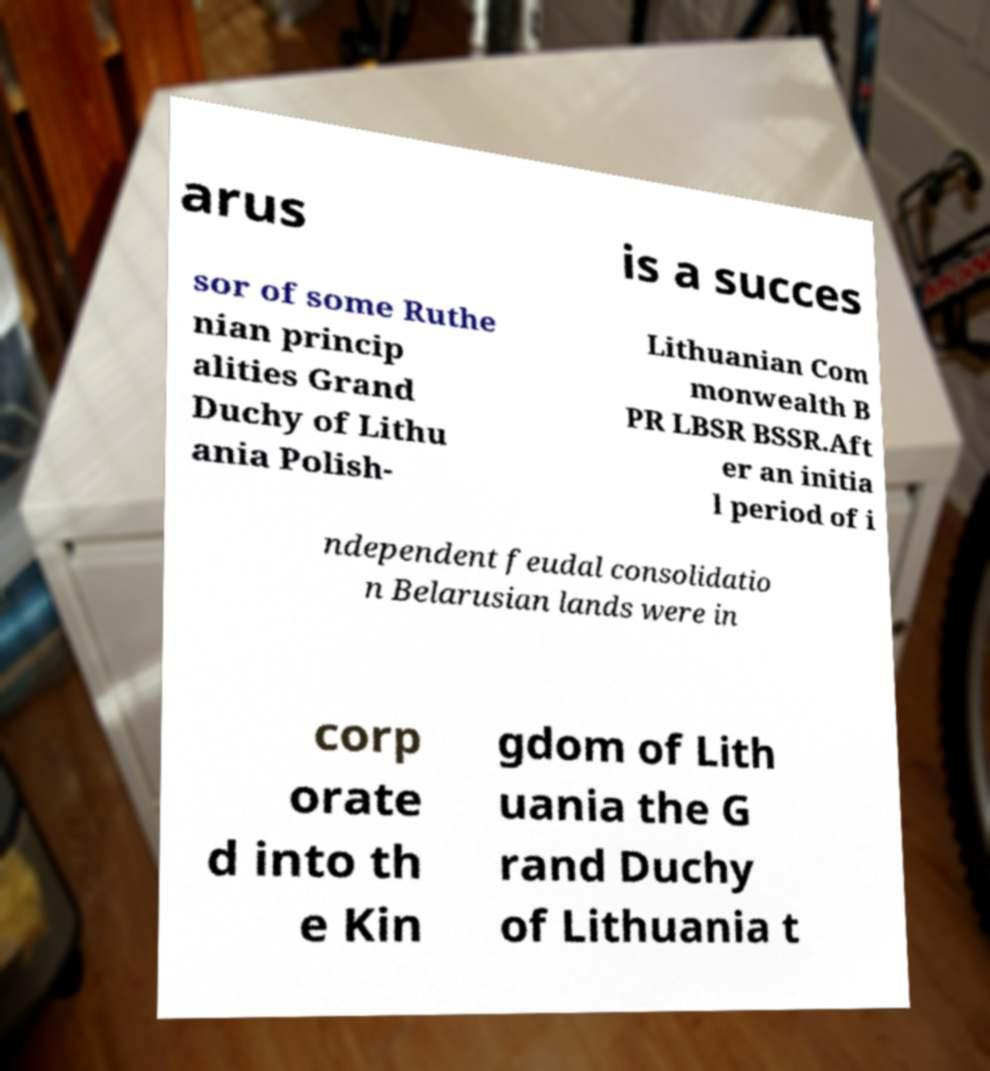Could you extract and type out the text from this image? arus is a succes sor of some Ruthe nian princip alities Grand Duchy of Lithu ania Polish- Lithuanian Com monwealth B PR LBSR BSSR.Aft er an initia l period of i ndependent feudal consolidatio n Belarusian lands were in corp orate d into th e Kin gdom of Lith uania the G rand Duchy of Lithuania t 